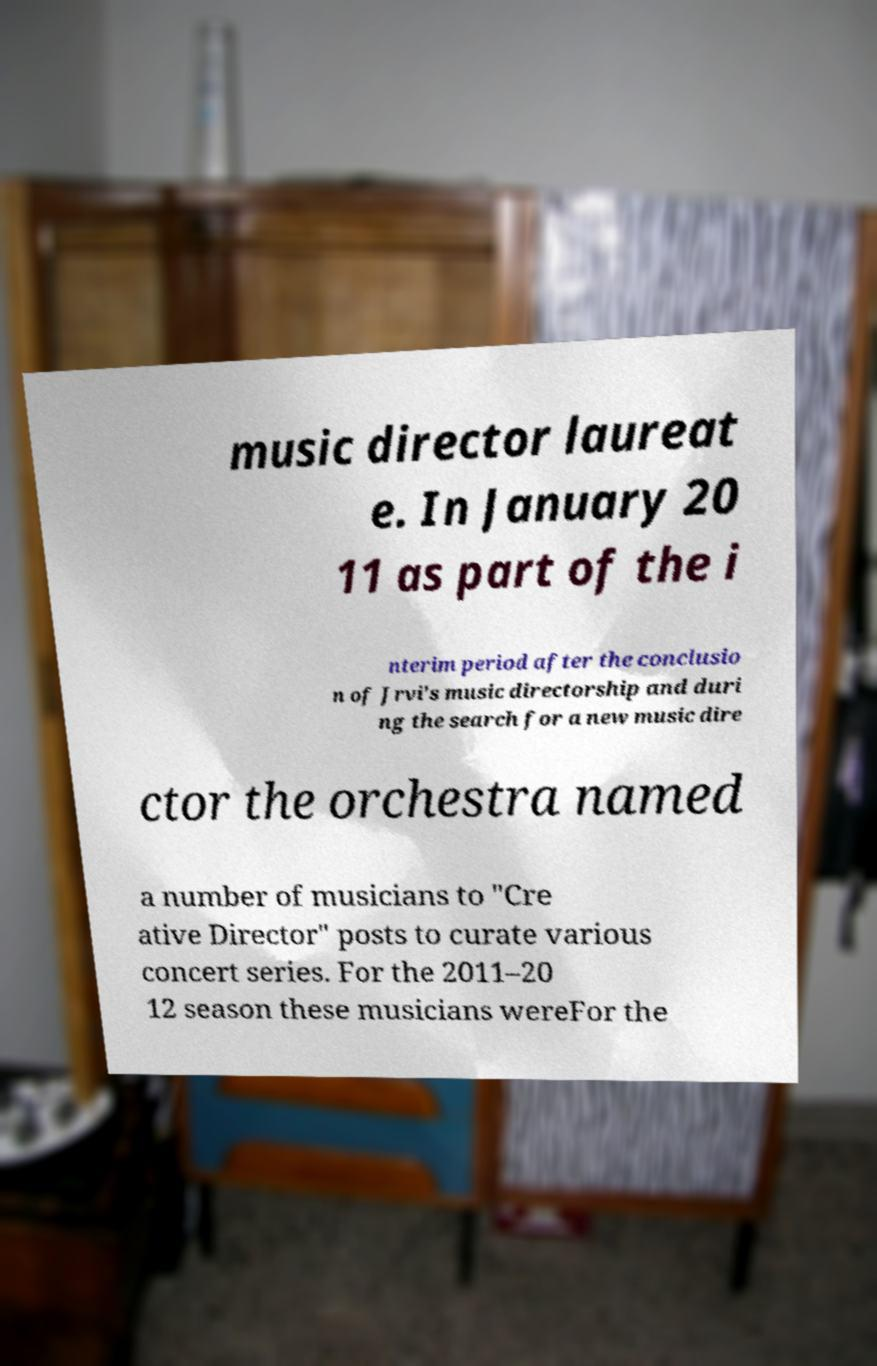I need the written content from this picture converted into text. Can you do that? music director laureat e. In January 20 11 as part of the i nterim period after the conclusio n of Jrvi's music directorship and duri ng the search for a new music dire ctor the orchestra named a number of musicians to "Cre ative Director" posts to curate various concert series. For the 2011–20 12 season these musicians wereFor the 